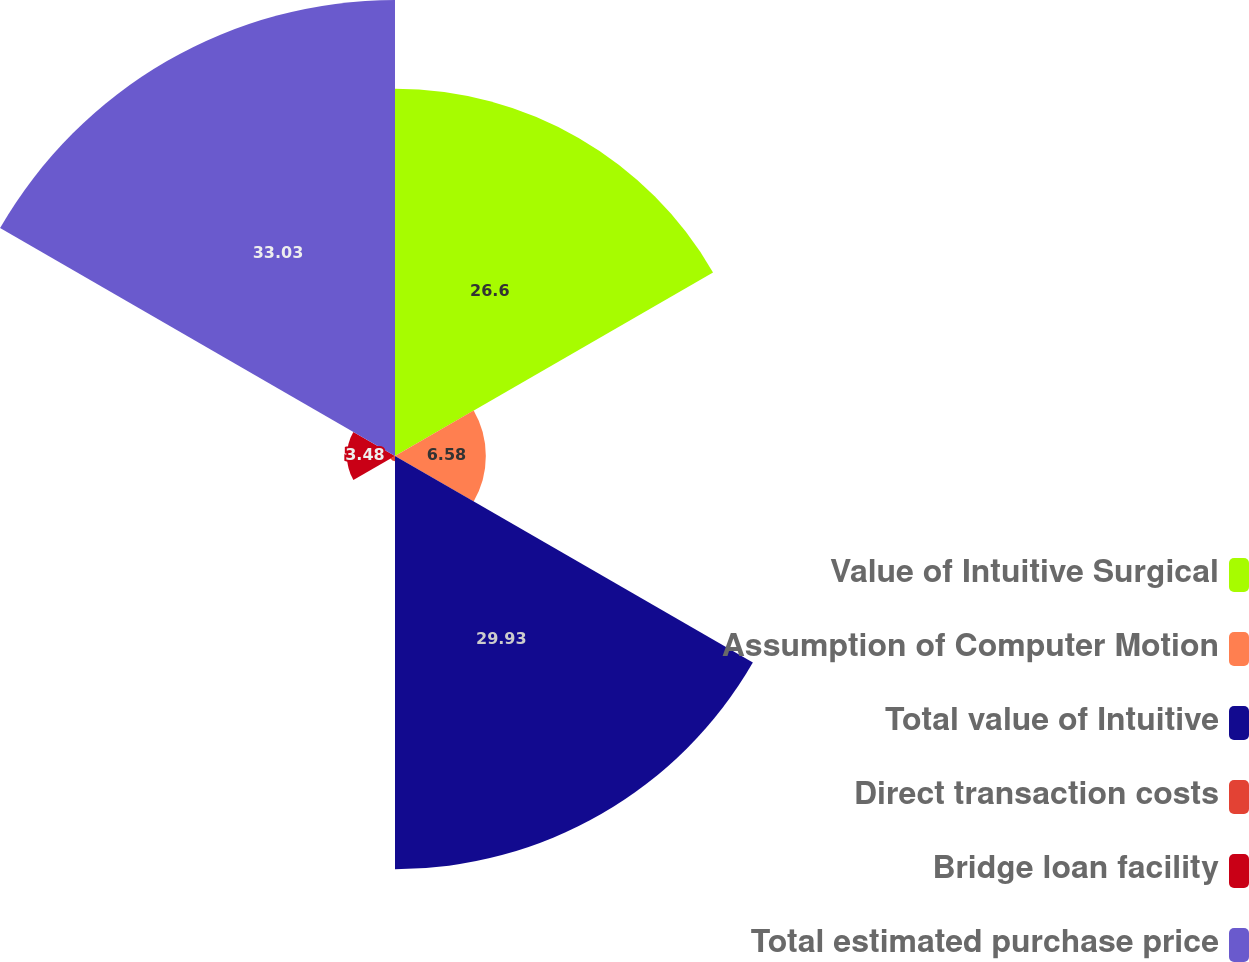Convert chart to OTSL. <chart><loc_0><loc_0><loc_500><loc_500><pie_chart><fcel>Value of Intuitive Surgical<fcel>Assumption of Computer Motion<fcel>Total value of Intuitive<fcel>Direct transaction costs<fcel>Bridge loan facility<fcel>Total estimated purchase price<nl><fcel>26.6%<fcel>6.58%<fcel>29.93%<fcel>0.38%<fcel>3.48%<fcel>33.03%<nl></chart> 